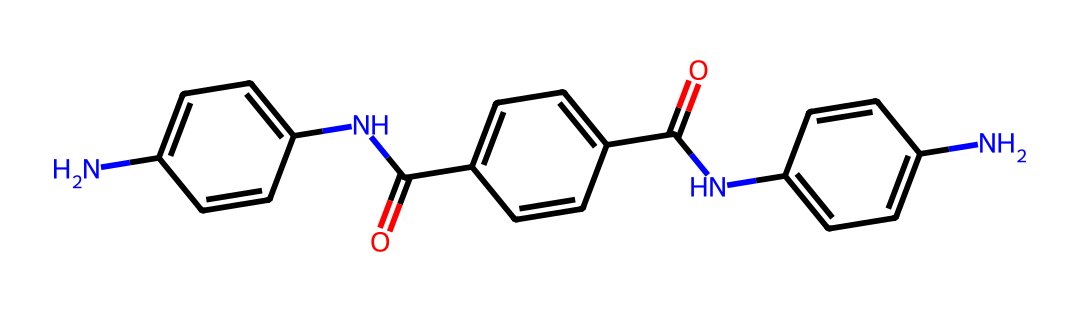What is the total number of nitrogen atoms in this chemical? By examining the chemical structure represented by the SMILES, I count three nitrogen (N) atoms present in the molecular structure.
Answer: three How many carbon atoms are present in this chemical? Counting the carbon (C) atoms in the SMILES notation, I find a total of sixteen carbon atoms.
Answer: sixteen What type of functional groups are present in this chemical? The SMILES shows the presence of amide functional groups indicated by the pattern "C(=O)N", which suggests multiple amides as part of the structure.
Answer: amide Which structural feature indicates that this chemical is a polymer? The presence of repeating motifs along with the amide linkages indicates that this compound may be forming polymers since these linkages are typical in polymers used for flame-retardant properties.
Answer: amide linkages What property of this chemical contributes to its flame-retardant nature? The amide groups within the chemical structure contribute to its ability to form char and limit flammability, making it suitable for flame-retardant materials.
Answer: char formation How many rings are present in the structure of this chemical? By analyzing the structure based on the SMILES notation, I observe that there are three distinct cyclic structures indicated, confirming the presence of multiple rings.
Answer: three 